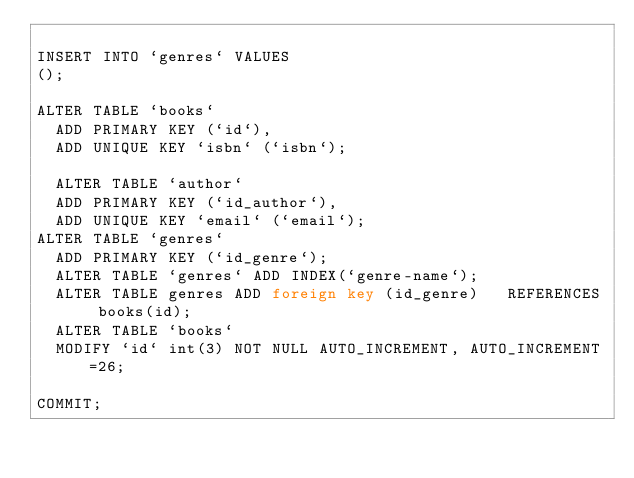Convert code to text. <code><loc_0><loc_0><loc_500><loc_500><_SQL_>
INSERT INTO `genres` VALUES
();

ALTER TABLE `books`
  ADD PRIMARY KEY (`id`),
  ADD UNIQUE KEY `isbn` (`isbn`);
  
  ALTER TABLE `author`
  ADD PRIMARY KEY (`id_author`),
  ADD UNIQUE KEY `email` (`email`);
ALTER TABLE `genres`
  ADD PRIMARY KEY (`id_genre`);
  ALTER TABLE `genres` ADD INDEX(`genre-name`);
  ALTER TABLE genres ADD foreign key (id_genre)   REFERENCES books(id);
  ALTER TABLE `books`
  MODIFY `id` int(3) NOT NULL AUTO_INCREMENT, AUTO_INCREMENT=26;

COMMIT;</code> 